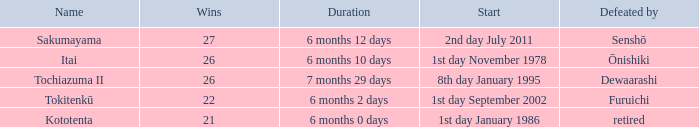Which duration was defeated by retired? 6 months 0 days. 